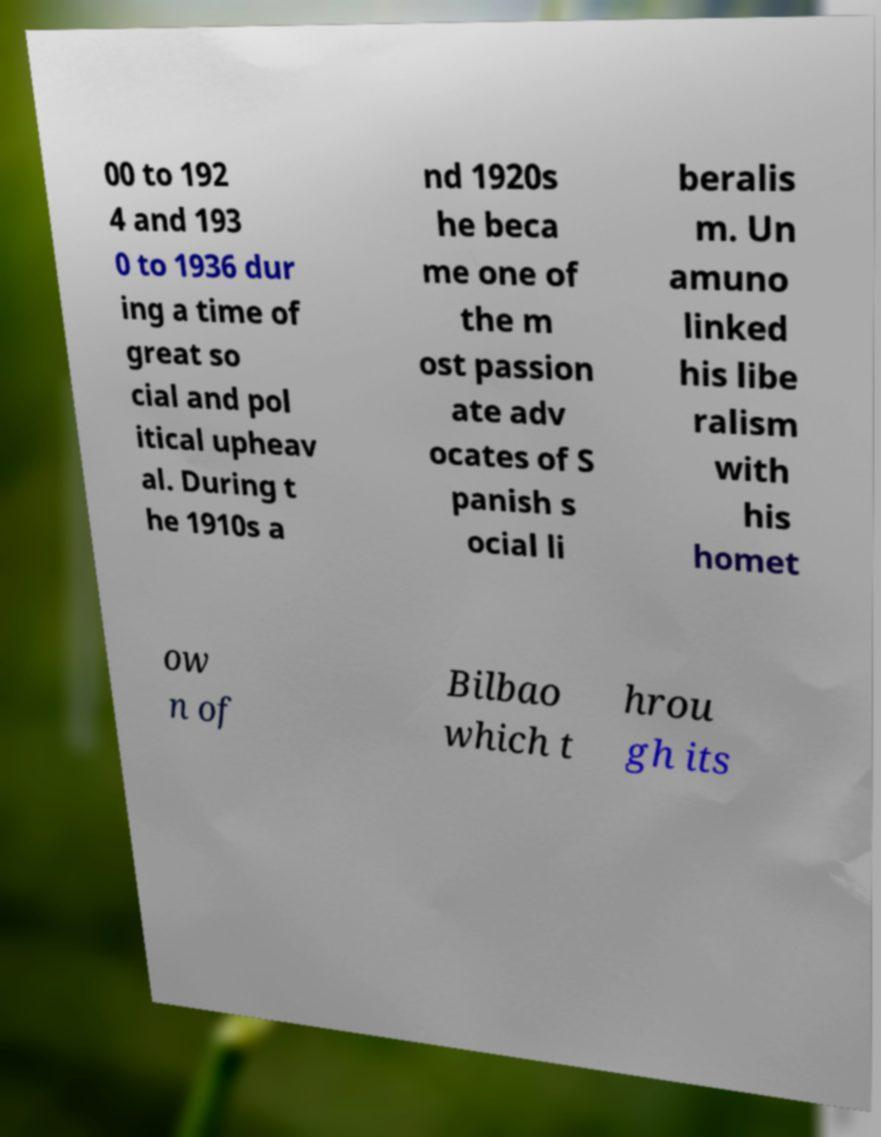For documentation purposes, I need the text within this image transcribed. Could you provide that? 00 to 192 4 and 193 0 to 1936 dur ing a time of great so cial and pol itical upheav al. During t he 1910s a nd 1920s he beca me one of the m ost passion ate adv ocates of S panish s ocial li beralis m. Un amuno linked his libe ralism with his homet ow n of Bilbao which t hrou gh its 